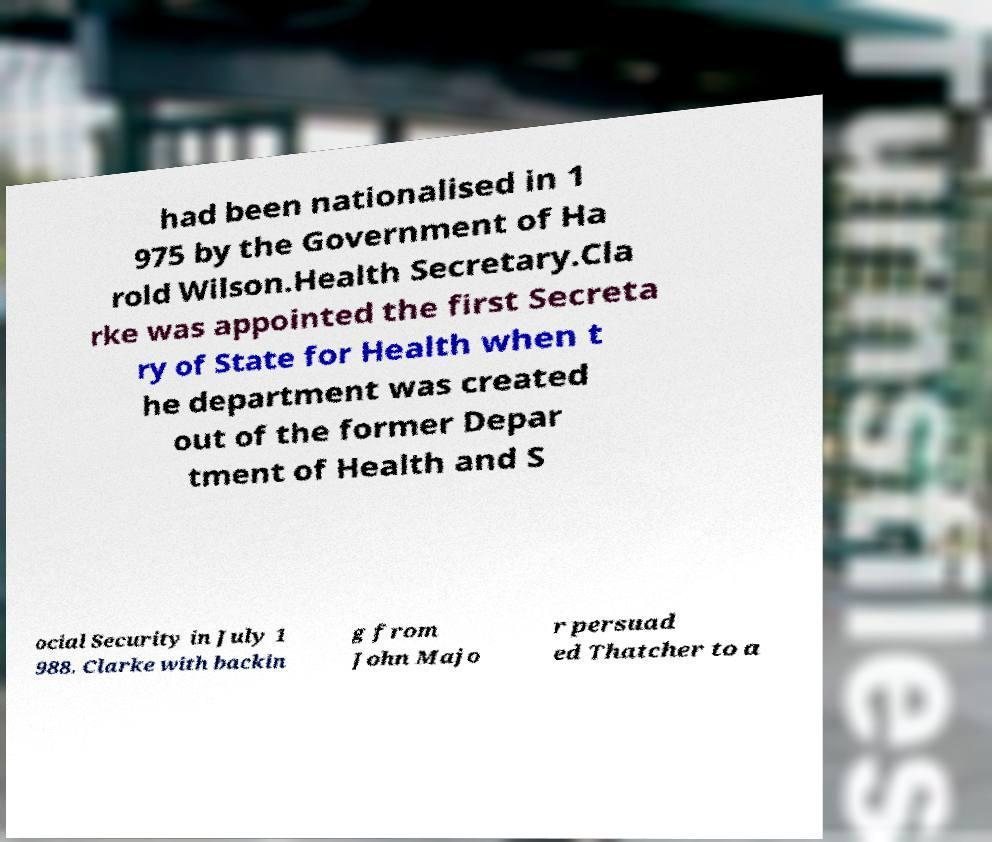Please read and relay the text visible in this image. What does it say? had been nationalised in 1 975 by the Government of Ha rold Wilson.Health Secretary.Cla rke was appointed the first Secreta ry of State for Health when t he department was created out of the former Depar tment of Health and S ocial Security in July 1 988. Clarke with backin g from John Majo r persuad ed Thatcher to a 